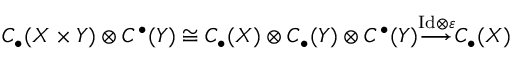<formula> <loc_0><loc_0><loc_500><loc_500>C _ { \bullet } ( X \times Y ) \otimes C ^ { \bullet } ( Y ) \cong C _ { \bullet } ( X ) \otimes C _ { \bullet } ( Y ) \otimes C ^ { \bullet } ( Y ) { \overset { I d \otimes \varepsilon } { \longrightarrow } } C _ { \bullet } ( X )</formula> 